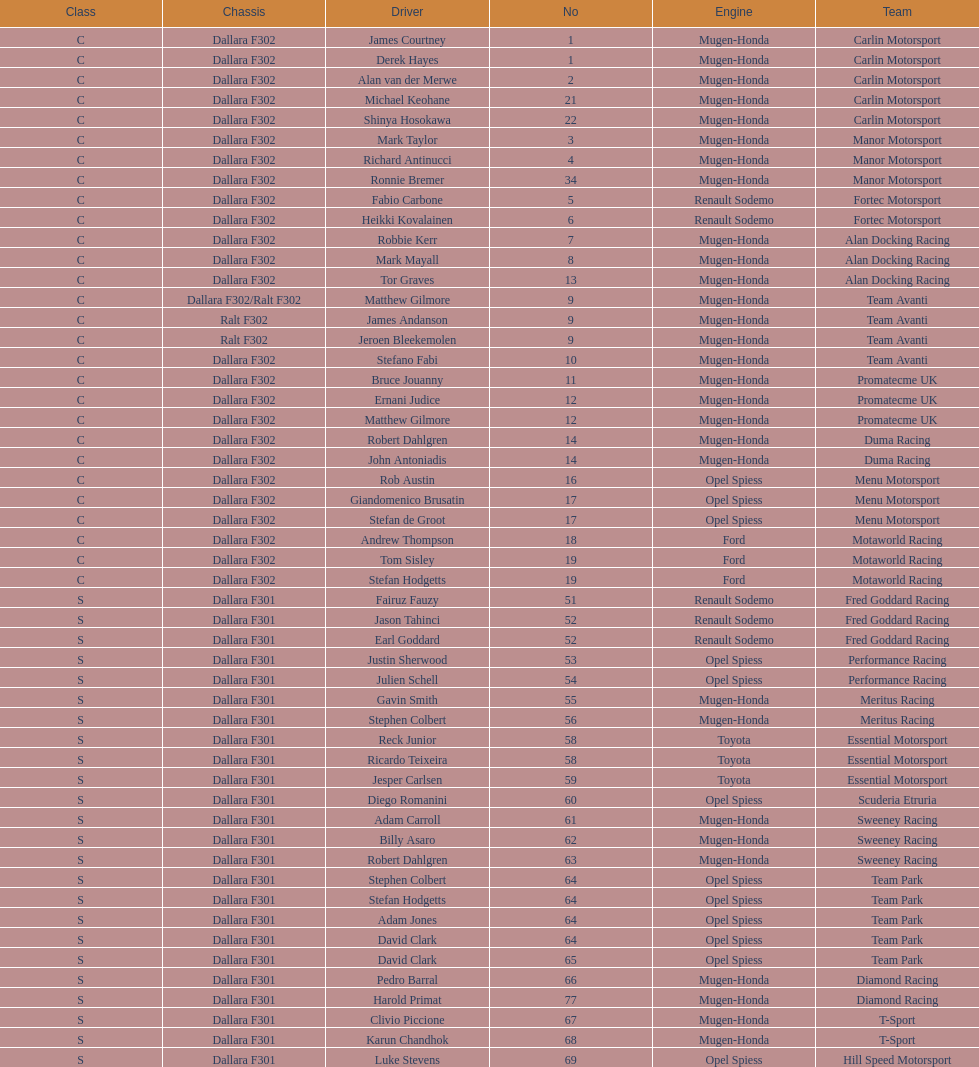How many class s (scholarship) teams are on the chart? 19. 